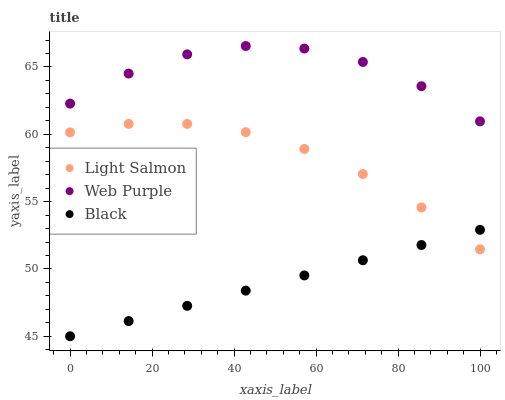Does Black have the minimum area under the curve?
Answer yes or no. Yes. Does Web Purple have the maximum area under the curve?
Answer yes or no. Yes. Does Web Purple have the minimum area under the curve?
Answer yes or no. No. Does Black have the maximum area under the curve?
Answer yes or no. No. Is Black the smoothest?
Answer yes or no. Yes. Is Web Purple the roughest?
Answer yes or no. Yes. Is Web Purple the smoothest?
Answer yes or no. No. Is Black the roughest?
Answer yes or no. No. Does Black have the lowest value?
Answer yes or no. Yes. Does Web Purple have the lowest value?
Answer yes or no. No. Does Web Purple have the highest value?
Answer yes or no. Yes. Does Black have the highest value?
Answer yes or no. No. Is Black less than Web Purple?
Answer yes or no. Yes. Is Web Purple greater than Black?
Answer yes or no. Yes. Does Light Salmon intersect Black?
Answer yes or no. Yes. Is Light Salmon less than Black?
Answer yes or no. No. Is Light Salmon greater than Black?
Answer yes or no. No. Does Black intersect Web Purple?
Answer yes or no. No. 